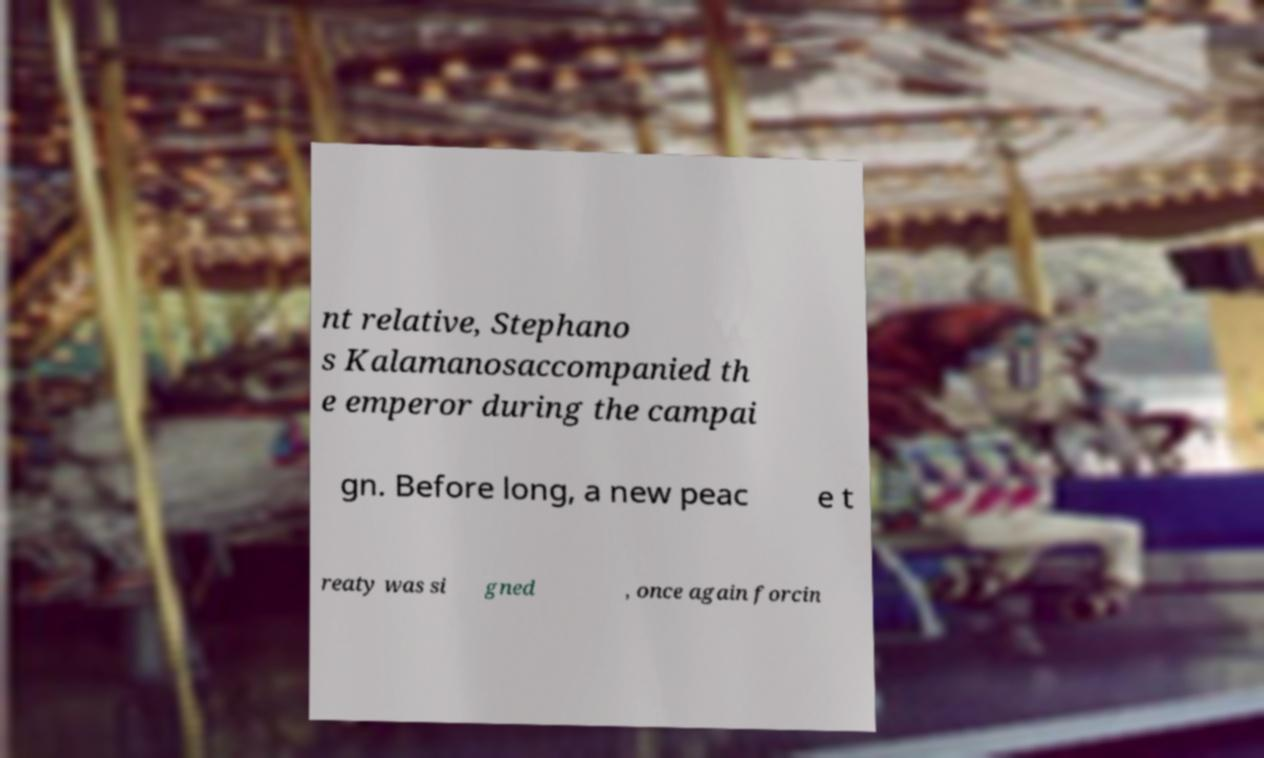Please identify and transcribe the text found in this image. nt relative, Stephano s Kalamanosaccompanied th e emperor during the campai gn. Before long, a new peac e t reaty was si gned , once again forcin 